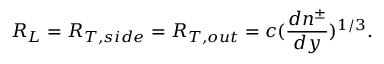Convert formula to latex. <formula><loc_0><loc_0><loc_500><loc_500>R _ { L } = R _ { T , s i d e } = R _ { T , o u t } = c ( { \frac { d n ^ { \pm } } { d y } } ) ^ { 1 / 3 } .</formula> 